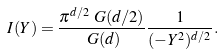Convert formula to latex. <formula><loc_0><loc_0><loc_500><loc_500>I ( Y ) & = \frac { \pi ^ { d / 2 } \ G ( d / 2 ) } { \ G ( d ) } \frac { 1 } { ( - Y ^ { 2 } ) ^ { d / 2 } } .</formula> 